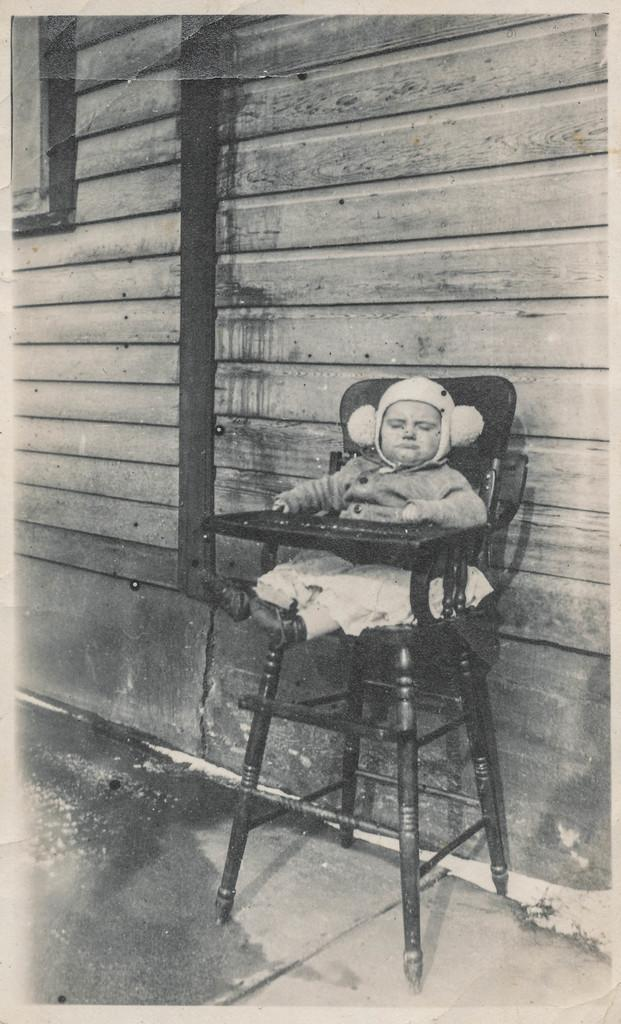What is the main subject of the image? The main subject of the image is a kid. What is the kid doing in the image? The kid is sitting on a chair in the image. What can be seen in the background of the image? There is a wall in the background of the image. What type of goat can be seen sitting next to the kid in the image? There is no goat present in the image; it only features a kid sitting on a chair. What type of quilt is covering the kid in the image? There is no quilt visible in the image; the kid is sitting on a chair without any covering. 